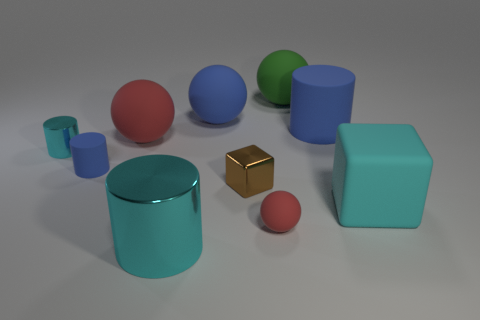Subtract all balls. How many objects are left? 6 Add 8 brown things. How many brown things exist? 9 Subtract 0 gray cubes. How many objects are left? 10 Subtract all balls. Subtract all big metallic objects. How many objects are left? 5 Add 4 small cyan metal things. How many small cyan metal things are left? 5 